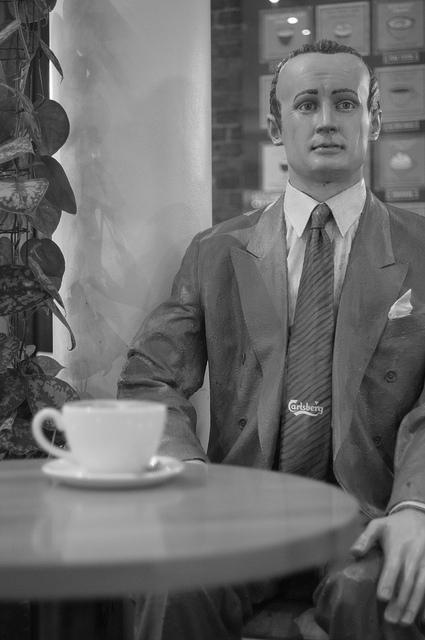How many people are in the picture?
Give a very brief answer. 1. 